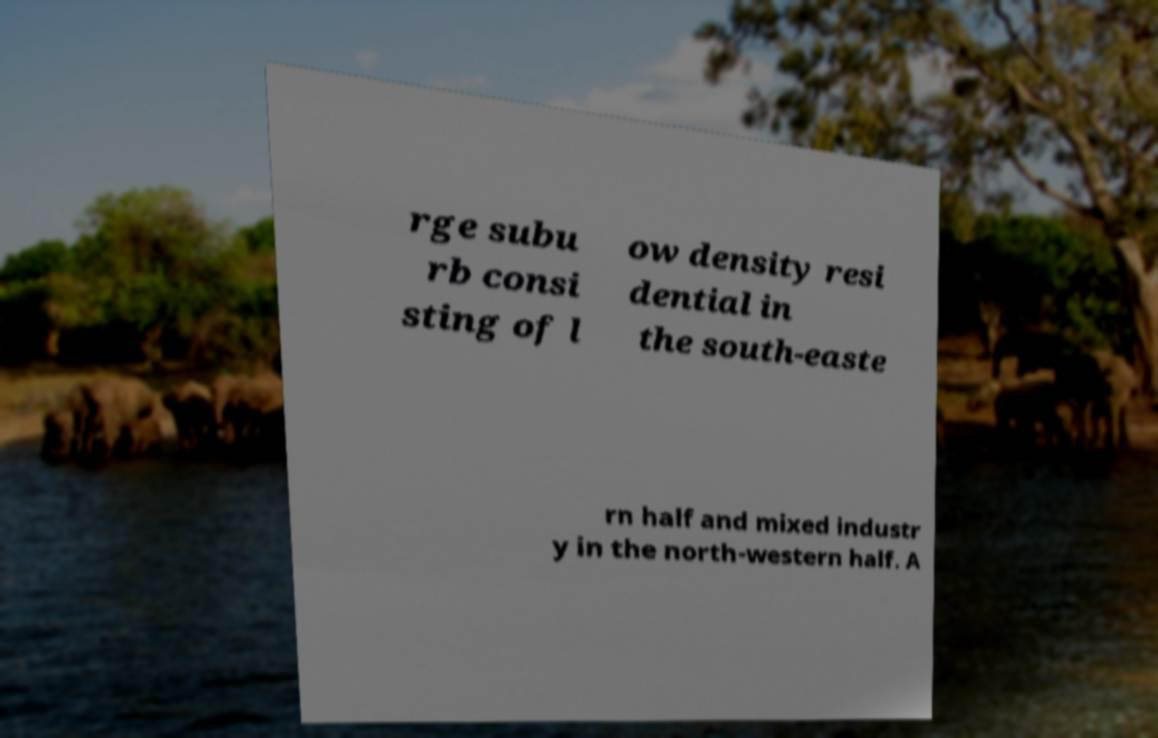Please read and relay the text visible in this image. What does it say? rge subu rb consi sting of l ow density resi dential in the south-easte rn half and mixed industr y in the north-western half. A 